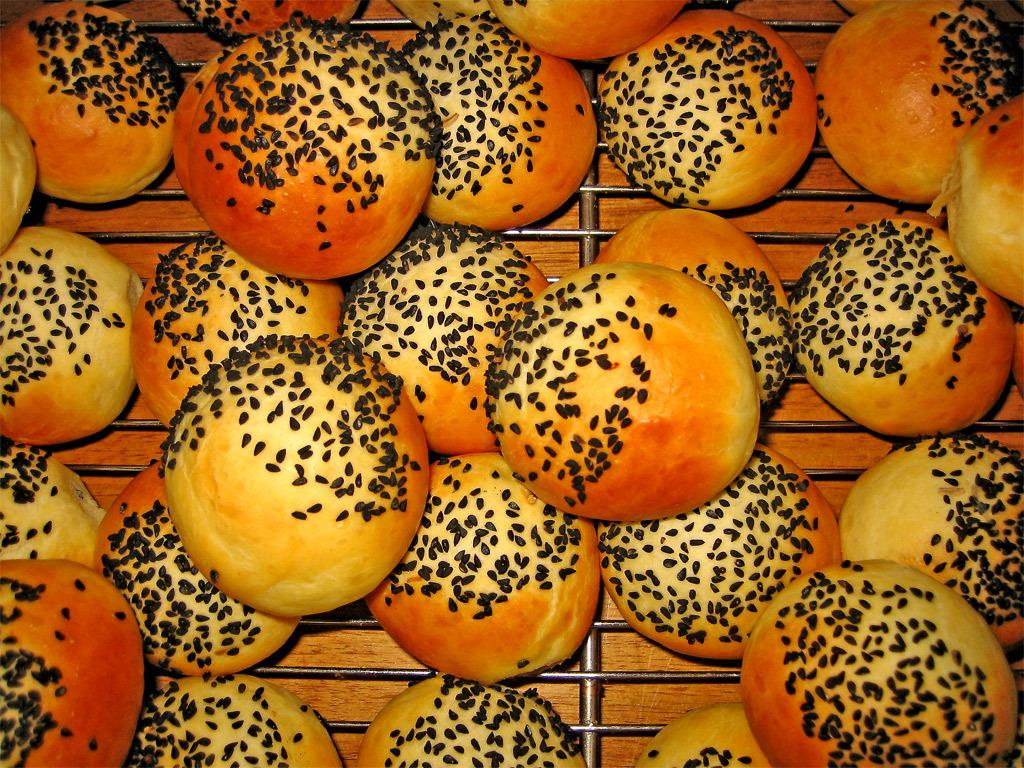What type of buns can be seen in the image? There are buns with sesame seeds in the image. How are the buns being prepared? The buns are placed on a grill. What can be seen in the background of the image? There is a wooden table in the background of the image. How many zebras are sitting at the table with the buns in the image? There are no zebras present in the image. What type of friends are sitting at the table with the buns in the image? There are no friends or people depicted in the image; it only shows buns on a grill and a wooden table in the background. 